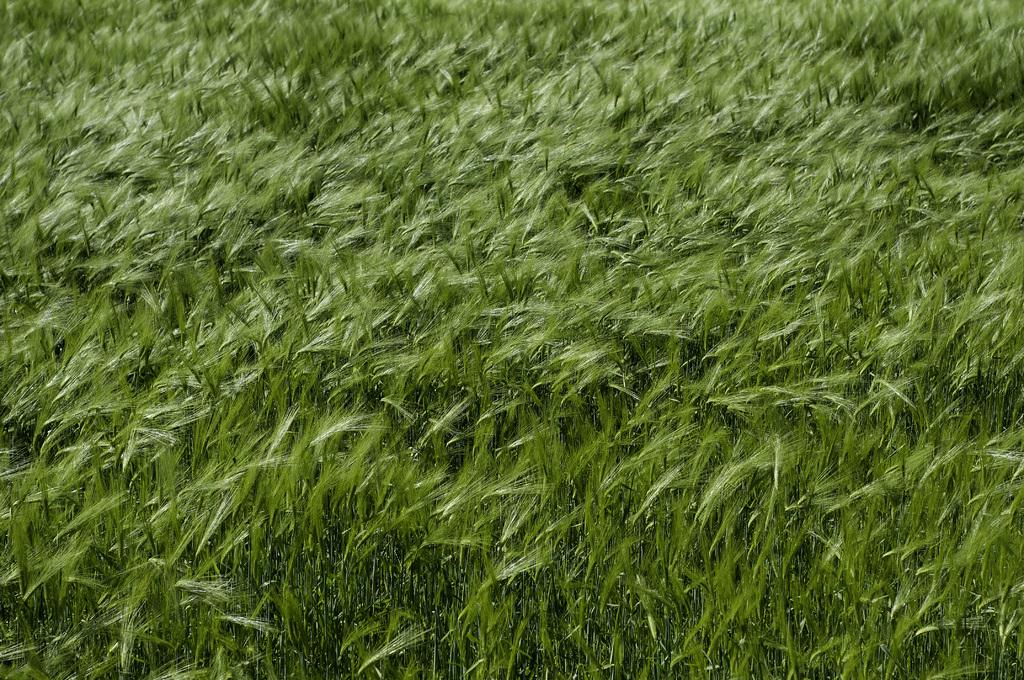What type of living organisms can be seen in the image? Plants can be seen in the image. What structural components are present in the plants? The plants have stems and leaves. What color are the plants in the image? The plants are green in color. What type of cactus is present on the page in the image? There is no cactus or page present in the image; it features plants with stems and leaves. 